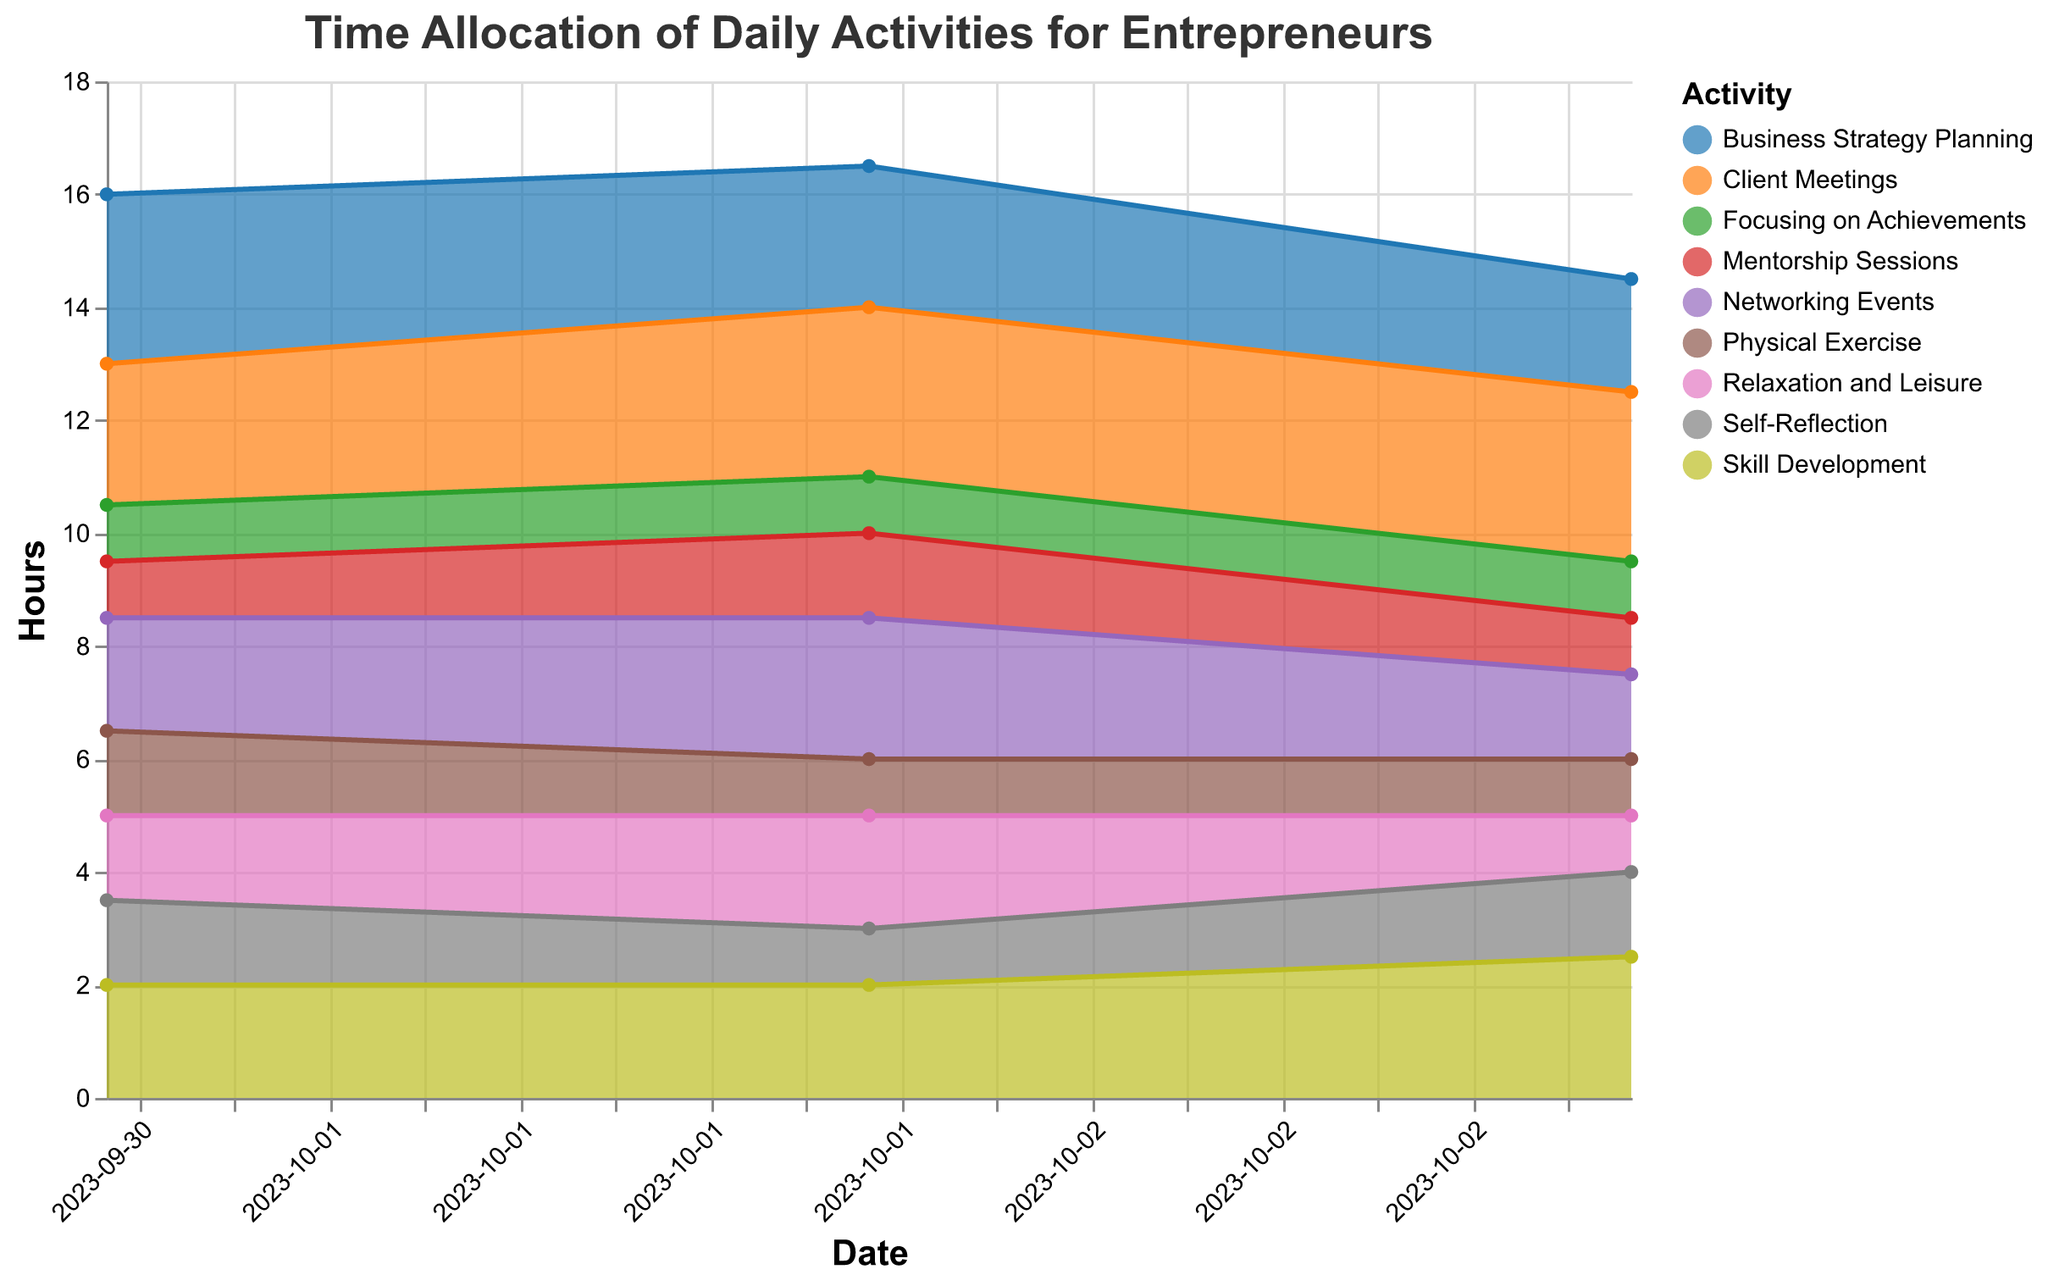Which activity takes the most hours on October 1st? Looking at the area chart for October 1st, the section representing Business Strategy Planning is the largest, indicating it takes the most time.
Answer: Business Strategy Planning How many hours are allocated to Self-Reflection on October 3rd? By examining the area chart on October 3rd, the Self-Reflection activity is marked and shows 1.5 hours.
Answer: 1.5 Which day had the highest total hours for Client Meetings? Comparing the area sizes for Client Meetings across all dates, October 2nd has the largest area, representing 3 hours.
Answer: October 2nd How does the time spent on Networking Events change over the three days? Following the color representing Networking Events over three days: it goes from 2 hours on October 1st to 2.5 hours on October 2nd and decreases to 1.5 hours on October 3rd.
Answer: 2 -> 2.5 -> 1.5 What is the total time spent on Physical Exercise across all three days? Adding the hours of Physical Exercise for each day: 1.5 (Oct 1) + 1 (Oct 2) + 1 (Oct 3) sums up to 3.5 hours.
Answer: 3.5 Compare the time spent on Focusing on Achievements and Mentorship Sessions on October 2nd. Which is more? On October 2nd, Focusing on Achievements is 1 hour and Mentorship Sessions are 1.5 hours, so Mentorship Sessions is more.
Answer: Mentorship Sessions Which activity maintains a consistent time allocation across all days? Examining each activity for consistent time allocation, Focusing on Achievements shows a consistent 1 hour each day.
Answer: Focusing on Achievements What is the average number of hours spent on Skill Development across the three days? Summing the Skill Development hours (2 on Oct 1, 2 on Oct 2, 2.5 on Oct 3) gives 6.5, divided by 3 days gives an average of approximately 2.17 hours.
Answer: 2.17 Which activity shows the most significant fluctuation in allocated time? Looking at the variations in area size over the days, Networking Events shows the most significant fluctuation from 2 hours to 2.5 hours to 1.5 hours.
Answer: Networking Events What was the least time-consuming activity on October 1st? Observing the smallest area on October 1st, Focusing on Achievements and Mentorship Sessions each take 1 hour, but among these two, any could be considered as least.
Answer: Focusing on Achievements, Mentorship Sessions 